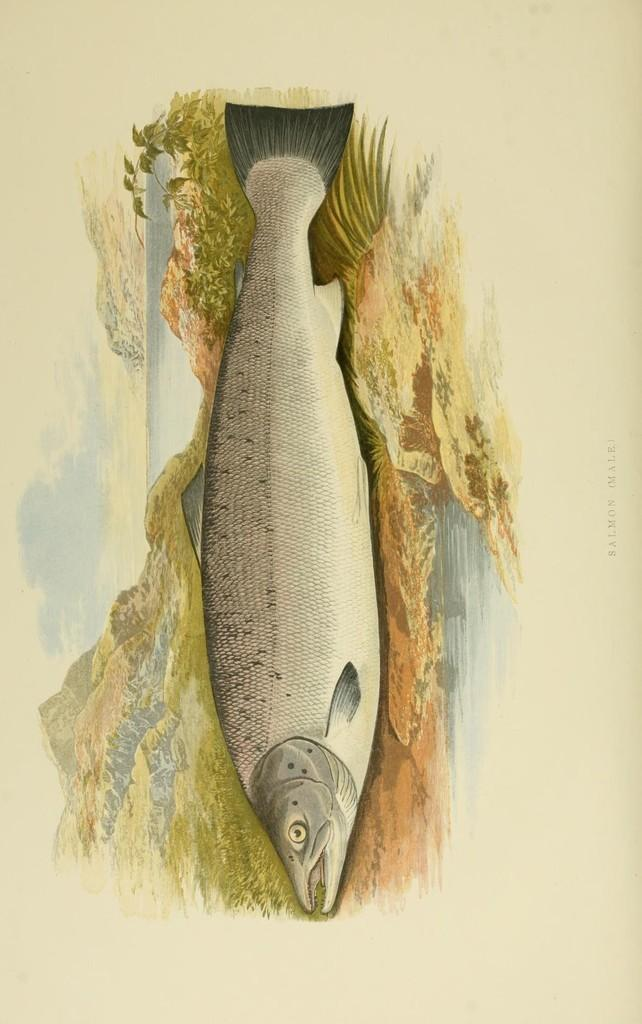What is the main subject of the image? The main subject of the image is a picture of a fish. Is there any smoke coming from the fish in the image? No, there is no smoke present in the image. How many chickens are visible in the image? There are no chickens present in the image; it features a picture of a fish. 